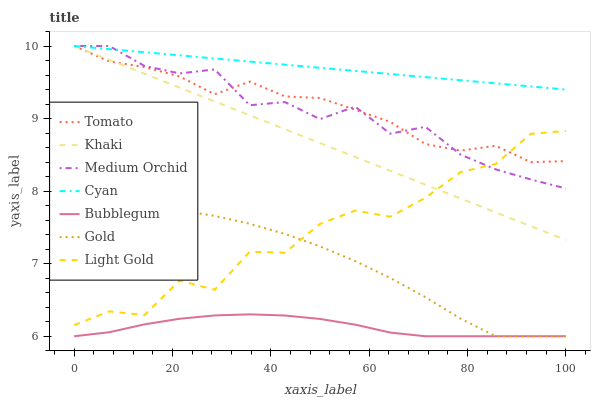Does Bubblegum have the minimum area under the curve?
Answer yes or no. Yes. Does Cyan have the maximum area under the curve?
Answer yes or no. Yes. Does Khaki have the minimum area under the curve?
Answer yes or no. No. Does Khaki have the maximum area under the curve?
Answer yes or no. No. Is Khaki the smoothest?
Answer yes or no. Yes. Is Light Gold the roughest?
Answer yes or no. Yes. Is Gold the smoothest?
Answer yes or no. No. Is Gold the roughest?
Answer yes or no. No. Does Gold have the lowest value?
Answer yes or no. Yes. Does Khaki have the lowest value?
Answer yes or no. No. Does Cyan have the highest value?
Answer yes or no. Yes. Does Gold have the highest value?
Answer yes or no. No. Is Light Gold less than Cyan?
Answer yes or no. Yes. Is Tomato greater than Bubblegum?
Answer yes or no. Yes. Does Tomato intersect Cyan?
Answer yes or no. Yes. Is Tomato less than Cyan?
Answer yes or no. No. Is Tomato greater than Cyan?
Answer yes or no. No. Does Light Gold intersect Cyan?
Answer yes or no. No. 